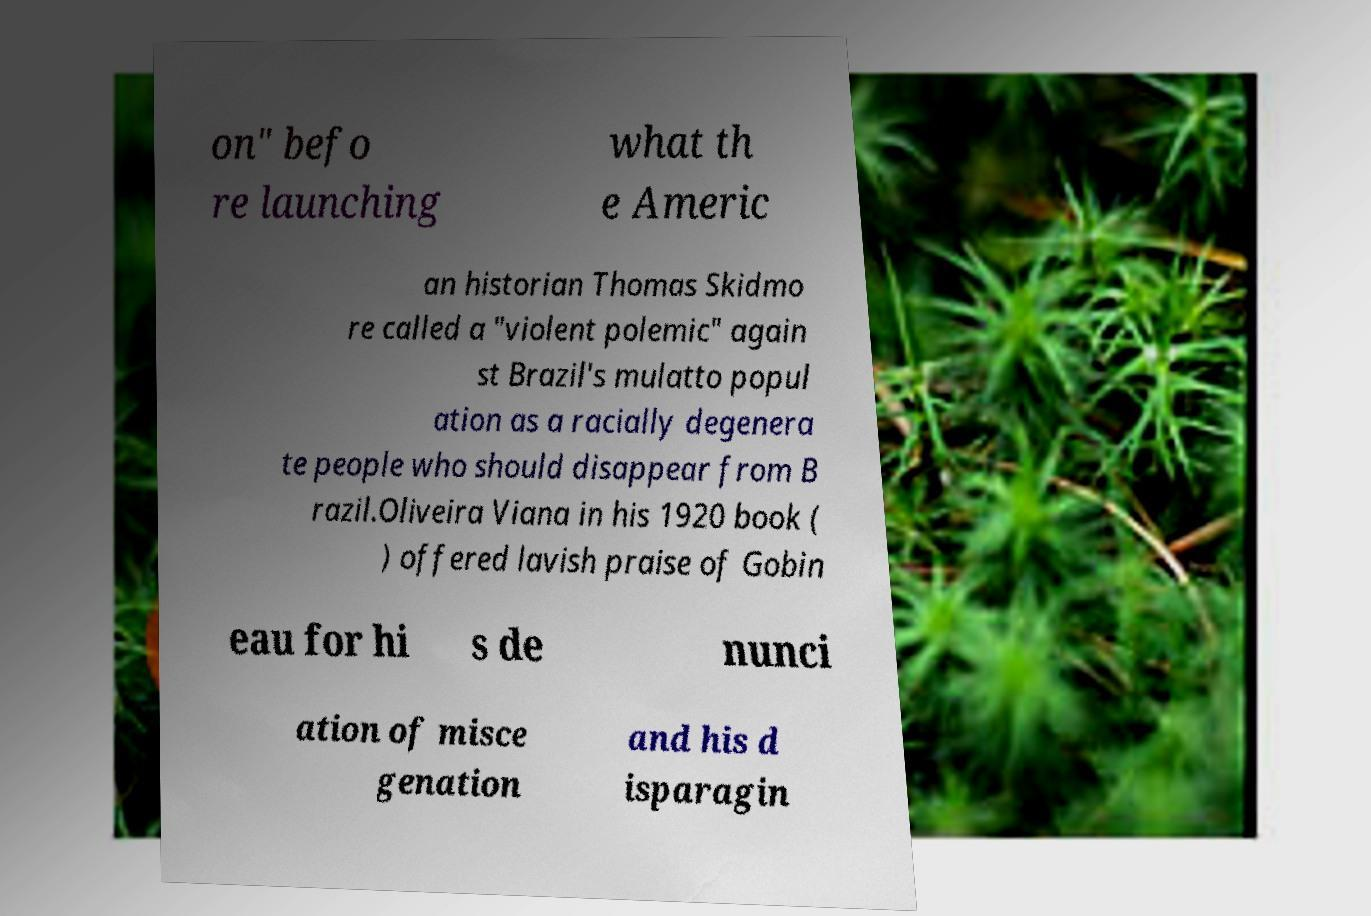Please read and relay the text visible in this image. What does it say? on" befo re launching what th e Americ an historian Thomas Skidmo re called a "violent polemic" again st Brazil's mulatto popul ation as a racially degenera te people who should disappear from B razil.Oliveira Viana in his 1920 book ( ) offered lavish praise of Gobin eau for hi s de nunci ation of misce genation and his d isparagin 